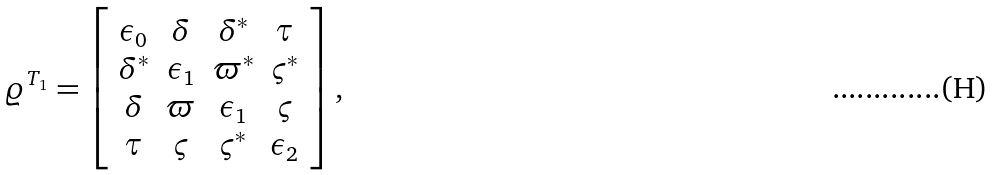Convert formula to latex. <formula><loc_0><loc_0><loc_500><loc_500>\varrho ^ { T _ { 1 } } = \left [ \begin{array} { c c c c } \epsilon _ { 0 } & \delta & \delta ^ { * } & \tau \\ \delta ^ { * } & \epsilon _ { 1 } & \varpi ^ { * } & \varsigma ^ { * } \\ \delta & \varpi & \epsilon _ { 1 } & \varsigma \\ \tau & \varsigma & \varsigma ^ { * } & \epsilon _ { 2 } \end{array} \right ] ,</formula> 